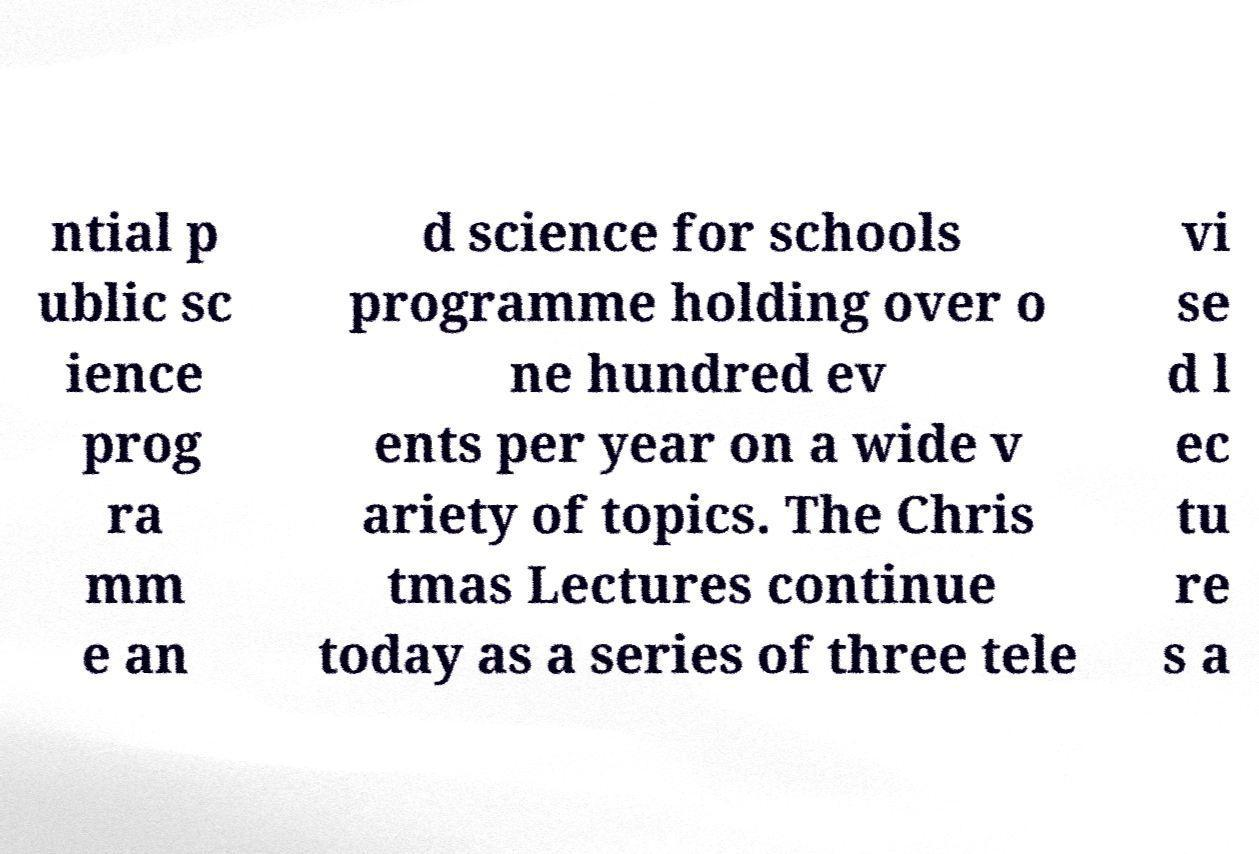There's text embedded in this image that I need extracted. Can you transcribe it verbatim? ntial p ublic sc ience prog ra mm e an d science for schools programme holding over o ne hundred ev ents per year on a wide v ariety of topics. The Chris tmas Lectures continue today as a series of three tele vi se d l ec tu re s a 